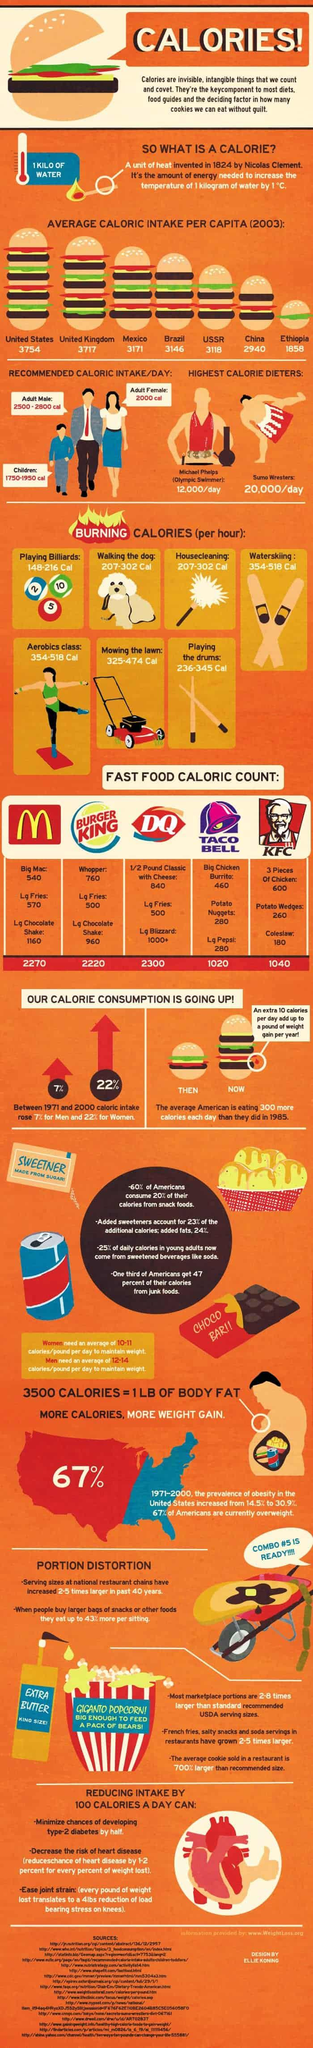Indicate a few pertinent items in this graphic. Taco Bell offers two menu items with a calorific count of 280, the Potato Nuggets and the Large Pepsi. In 2003, China and Ethiopia had average caloric intake per capita that was less than 3000, indicating a lack of adequate nutrition for the population in these countries. Seventeen sources are listed at the bottom. Walking the dog and housecleaning are two activities that can help burn 207-302 calories per hour. It is estimated that over 75% of daily calories consumed by young adults do not come from sweetened beverages. 